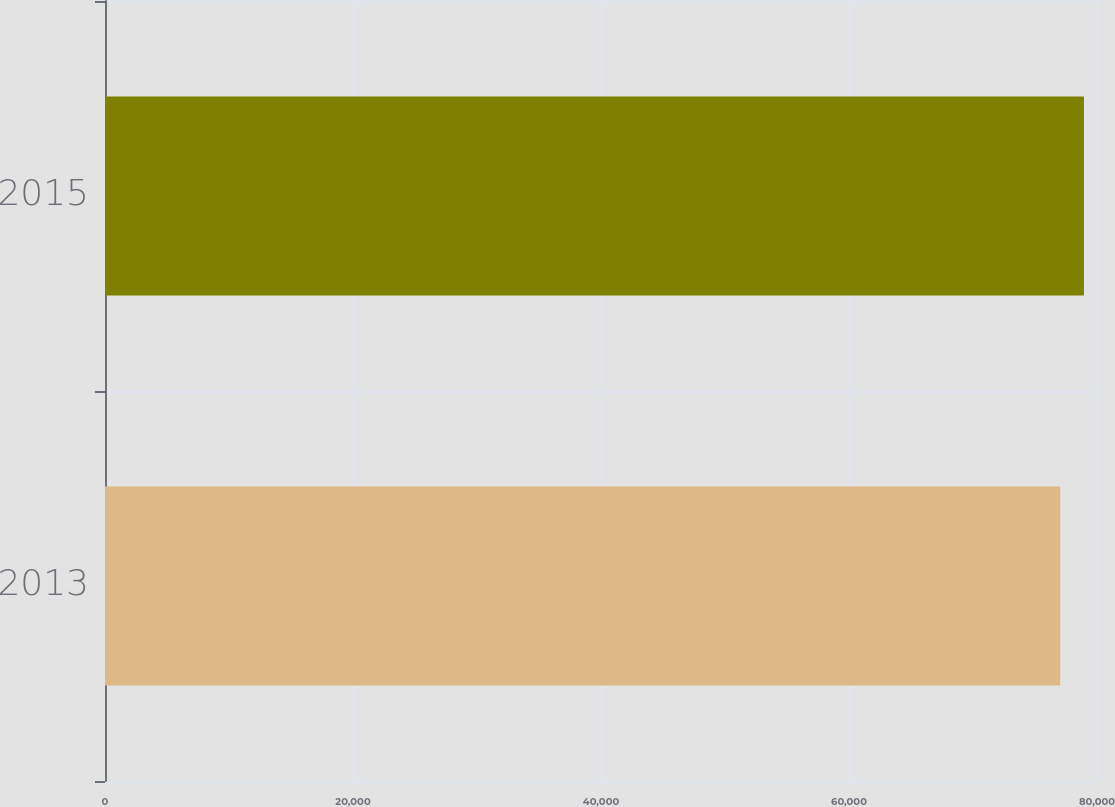<chart> <loc_0><loc_0><loc_500><loc_500><bar_chart><fcel>2013<fcel>2015<nl><fcel>77037<fcel>78947<nl></chart> 